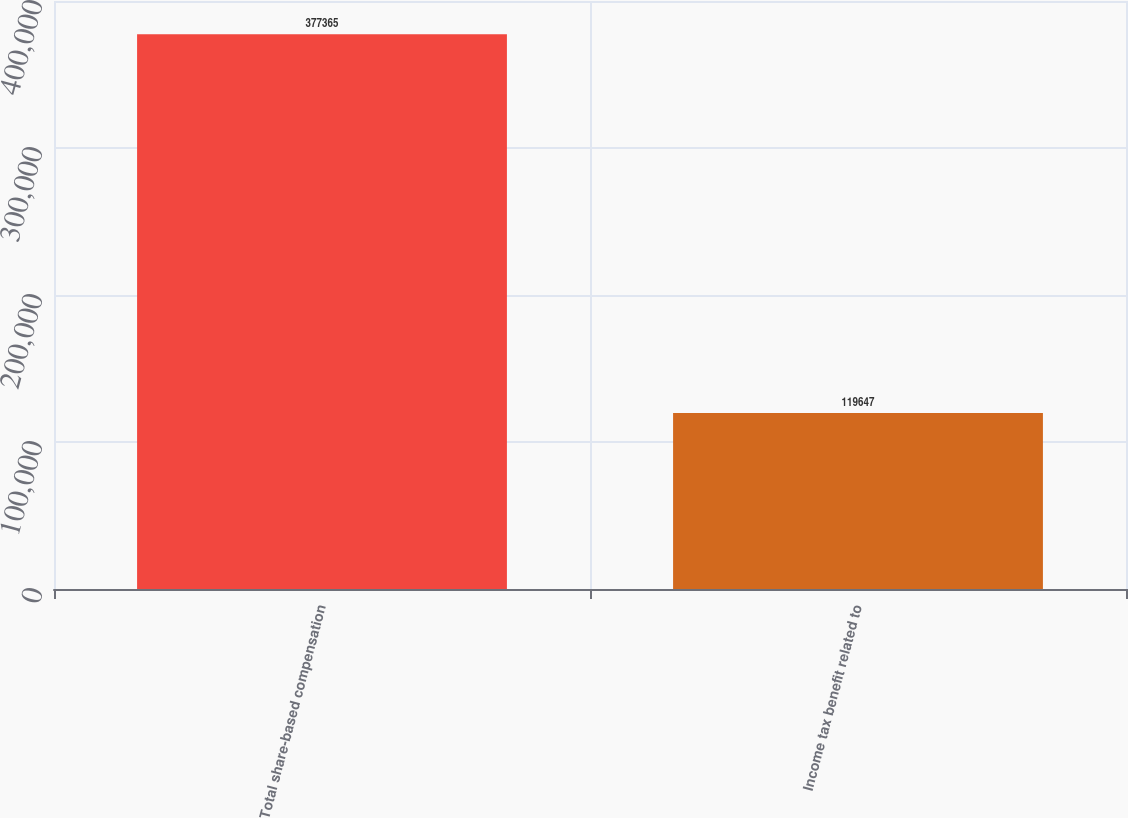Convert chart to OTSL. <chart><loc_0><loc_0><loc_500><loc_500><bar_chart><fcel>Total share-based compensation<fcel>Income tax benefit related to<nl><fcel>377365<fcel>119647<nl></chart> 